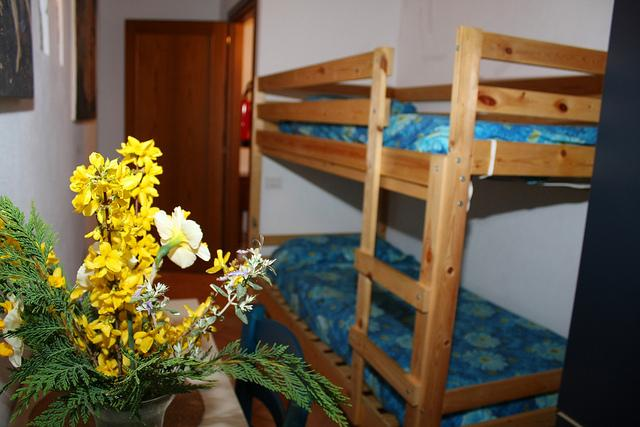What type of bed is shown? Please explain your reasoning. bunk bed. A bed frame holding two beds, one above the other is shown. bunk beds have two beds. 